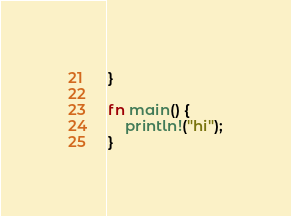<code> <loc_0><loc_0><loc_500><loc_500><_Rust_>}

fn main() {
    println!("hi");
}
</code> 